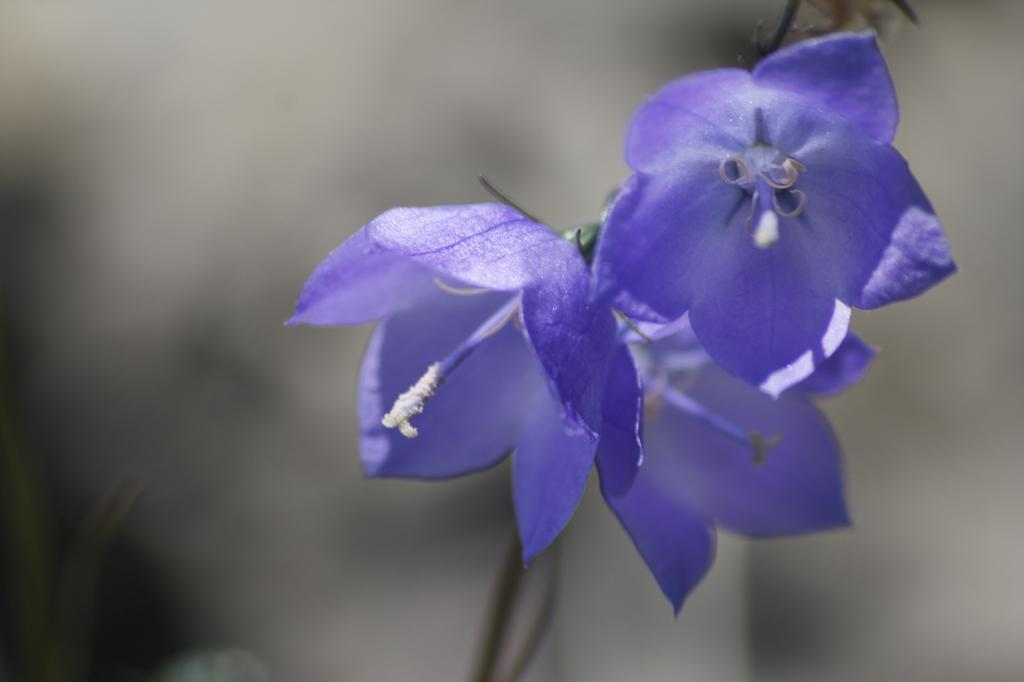What color are the flowers in the image? The flowers in the image are violet. Can you describe the background of the image? The background of the image is blurry. What type of suit is the person wearing on the coast in the image? There is no person or coast present in the image; it only features violet flowers with a blurry background. 